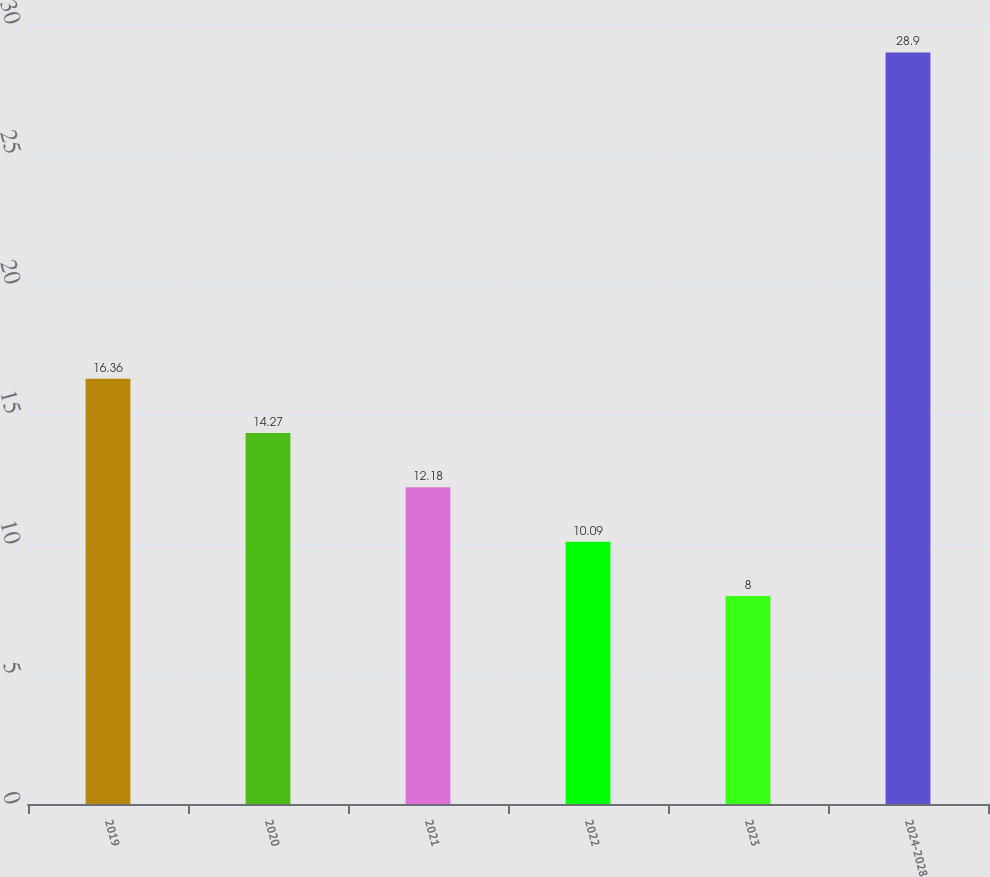Convert chart to OTSL. <chart><loc_0><loc_0><loc_500><loc_500><bar_chart><fcel>2019<fcel>2020<fcel>2021<fcel>2022<fcel>2023<fcel>2024-2028<nl><fcel>16.36<fcel>14.27<fcel>12.18<fcel>10.09<fcel>8<fcel>28.9<nl></chart> 